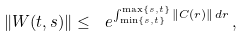<formula> <loc_0><loc_0><loc_500><loc_500>\left \| W ( t , s ) \right \| \leq \ e ^ { \int _ { \min \{ s , t \} } ^ { \max \{ s , t \} } \| C ( r ) \| \, d r } \, ,</formula> 